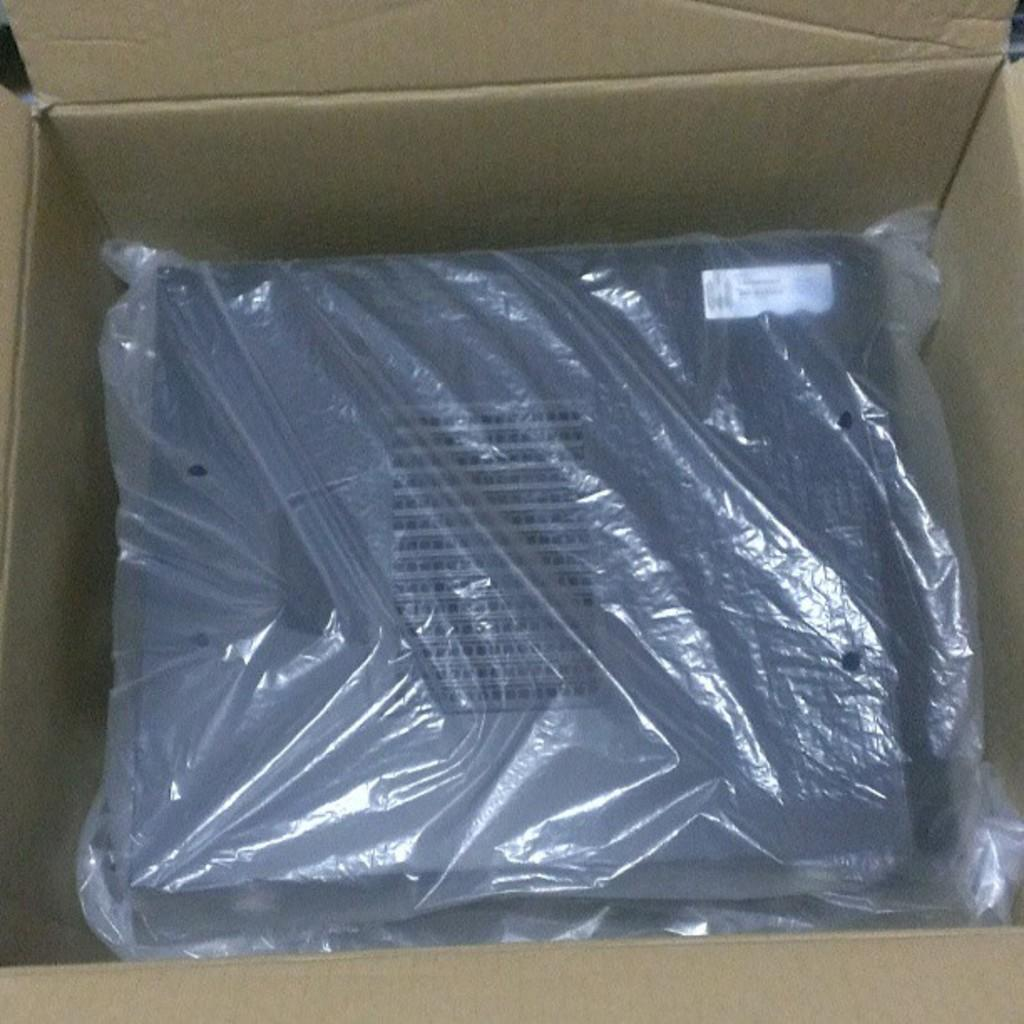What is present in the image? There is a cardboard box in the image. What is inside the cardboard box? There is an object inside the cardboard box. How is the object inside the cardboard box being concealed? The object is covered with a cover. What type of discovery was made by the person who kissed the object inside the cardboard box in the image? There is no person, kiss, or discovery present in the image. The object inside the cardboard box is simply covered with a cover. 